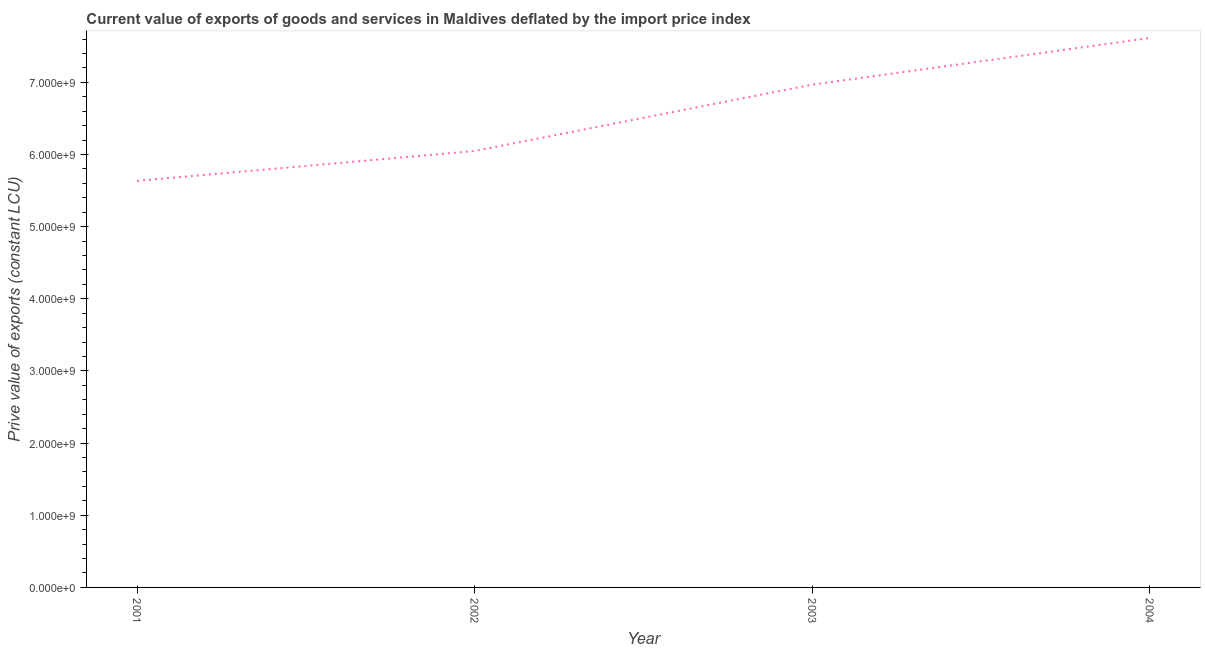What is the price value of exports in 2004?
Ensure brevity in your answer.  7.61e+09. Across all years, what is the maximum price value of exports?
Offer a terse response. 7.61e+09. Across all years, what is the minimum price value of exports?
Make the answer very short. 5.63e+09. In which year was the price value of exports maximum?
Your response must be concise. 2004. In which year was the price value of exports minimum?
Offer a very short reply. 2001. What is the sum of the price value of exports?
Your answer should be compact. 2.63e+1. What is the difference between the price value of exports in 2002 and 2003?
Offer a very short reply. -9.20e+08. What is the average price value of exports per year?
Give a very brief answer. 6.57e+09. What is the median price value of exports?
Offer a terse response. 6.51e+09. Do a majority of the years between 2001 and 2003 (inclusive) have price value of exports greater than 3800000000 LCU?
Give a very brief answer. Yes. What is the ratio of the price value of exports in 2002 to that in 2003?
Your response must be concise. 0.87. Is the difference between the price value of exports in 2003 and 2004 greater than the difference between any two years?
Offer a very short reply. No. What is the difference between the highest and the second highest price value of exports?
Your response must be concise. 6.47e+08. Is the sum of the price value of exports in 2002 and 2003 greater than the maximum price value of exports across all years?
Offer a very short reply. Yes. What is the difference between the highest and the lowest price value of exports?
Your response must be concise. 1.98e+09. In how many years, is the price value of exports greater than the average price value of exports taken over all years?
Provide a succinct answer. 2. Does the price value of exports monotonically increase over the years?
Provide a short and direct response. Yes. How many lines are there?
Provide a succinct answer. 1. What is the difference between two consecutive major ticks on the Y-axis?
Provide a short and direct response. 1.00e+09. What is the title of the graph?
Provide a succinct answer. Current value of exports of goods and services in Maldives deflated by the import price index. What is the label or title of the Y-axis?
Your answer should be compact. Prive value of exports (constant LCU). What is the Prive value of exports (constant LCU) in 2001?
Provide a short and direct response. 5.63e+09. What is the Prive value of exports (constant LCU) in 2002?
Keep it short and to the point. 6.05e+09. What is the Prive value of exports (constant LCU) of 2003?
Your response must be concise. 6.97e+09. What is the Prive value of exports (constant LCU) of 2004?
Give a very brief answer. 7.61e+09. What is the difference between the Prive value of exports (constant LCU) in 2001 and 2002?
Keep it short and to the point. -4.14e+08. What is the difference between the Prive value of exports (constant LCU) in 2001 and 2003?
Make the answer very short. -1.33e+09. What is the difference between the Prive value of exports (constant LCU) in 2001 and 2004?
Offer a very short reply. -1.98e+09. What is the difference between the Prive value of exports (constant LCU) in 2002 and 2003?
Your answer should be very brief. -9.20e+08. What is the difference between the Prive value of exports (constant LCU) in 2002 and 2004?
Your response must be concise. -1.57e+09. What is the difference between the Prive value of exports (constant LCU) in 2003 and 2004?
Your answer should be very brief. -6.47e+08. What is the ratio of the Prive value of exports (constant LCU) in 2001 to that in 2002?
Your response must be concise. 0.93. What is the ratio of the Prive value of exports (constant LCU) in 2001 to that in 2003?
Provide a succinct answer. 0.81. What is the ratio of the Prive value of exports (constant LCU) in 2001 to that in 2004?
Make the answer very short. 0.74. What is the ratio of the Prive value of exports (constant LCU) in 2002 to that in 2003?
Your answer should be very brief. 0.87. What is the ratio of the Prive value of exports (constant LCU) in 2002 to that in 2004?
Give a very brief answer. 0.79. What is the ratio of the Prive value of exports (constant LCU) in 2003 to that in 2004?
Provide a short and direct response. 0.92. 